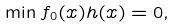<formula> <loc_0><loc_0><loc_500><loc_500>\min f _ { 0 } ( x ) h ( x ) = 0 ,</formula> 